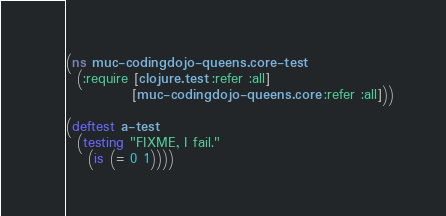Convert code to text. <code><loc_0><loc_0><loc_500><loc_500><_Clojure_>(ns muc-codingdojo-queens.core-test
  (:require [clojure.test :refer :all]
            [muc-codingdojo-queens.core :refer :all]))

(deftest a-test
  (testing "FIXME, I fail."
    (is (= 0 1))))
</code> 